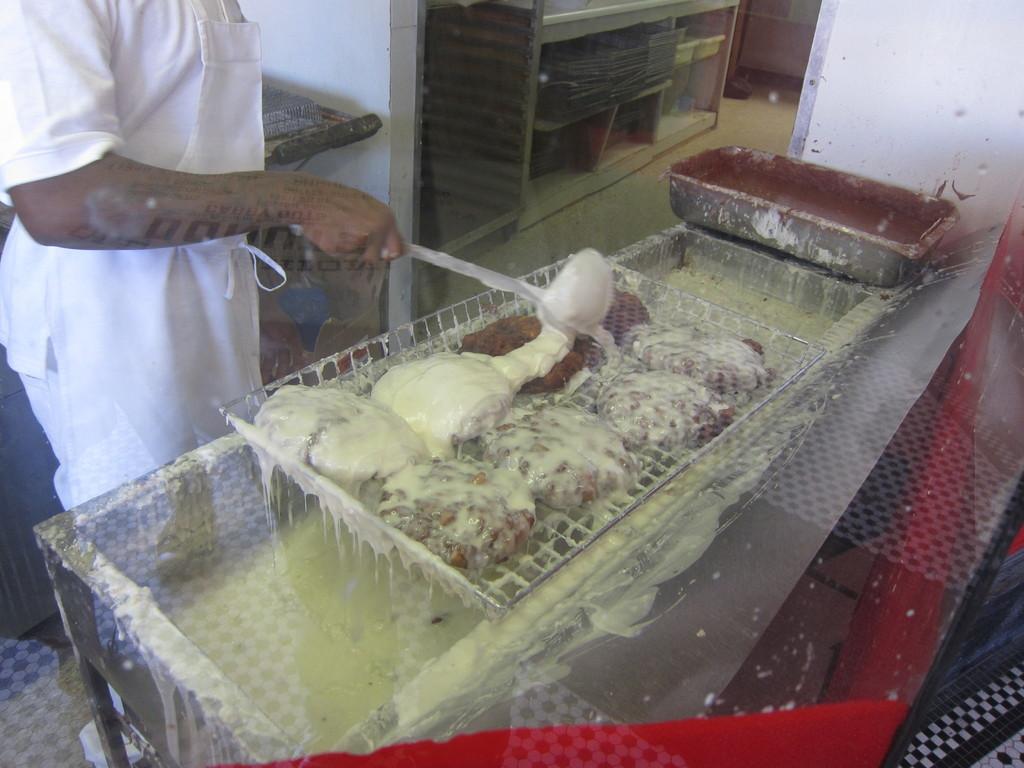Please provide a concise description of this image. In this image I can see in the middle there are food items. In the left hand side top a person is standing and making the food items, this person is wearing the white color dress. It look like a kitchen room. 